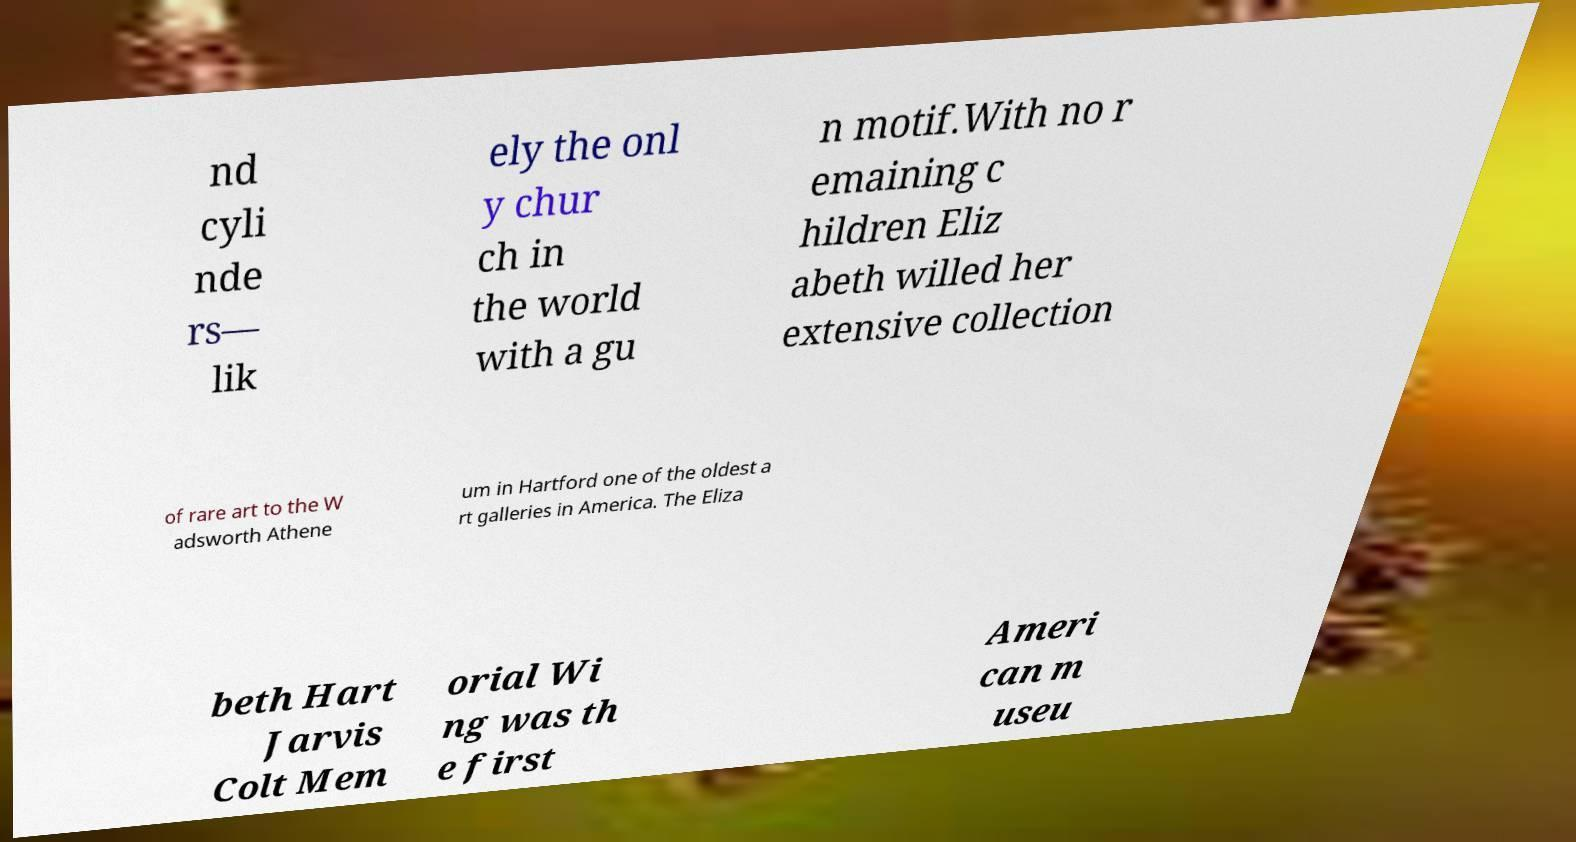Could you assist in decoding the text presented in this image and type it out clearly? nd cyli nde rs— lik ely the onl y chur ch in the world with a gu n motif.With no r emaining c hildren Eliz abeth willed her extensive collection of rare art to the W adsworth Athene um in Hartford one of the oldest a rt galleries in America. The Eliza beth Hart Jarvis Colt Mem orial Wi ng was th e first Ameri can m useu 